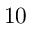<formula> <loc_0><loc_0><loc_500><loc_500>1 0</formula> 